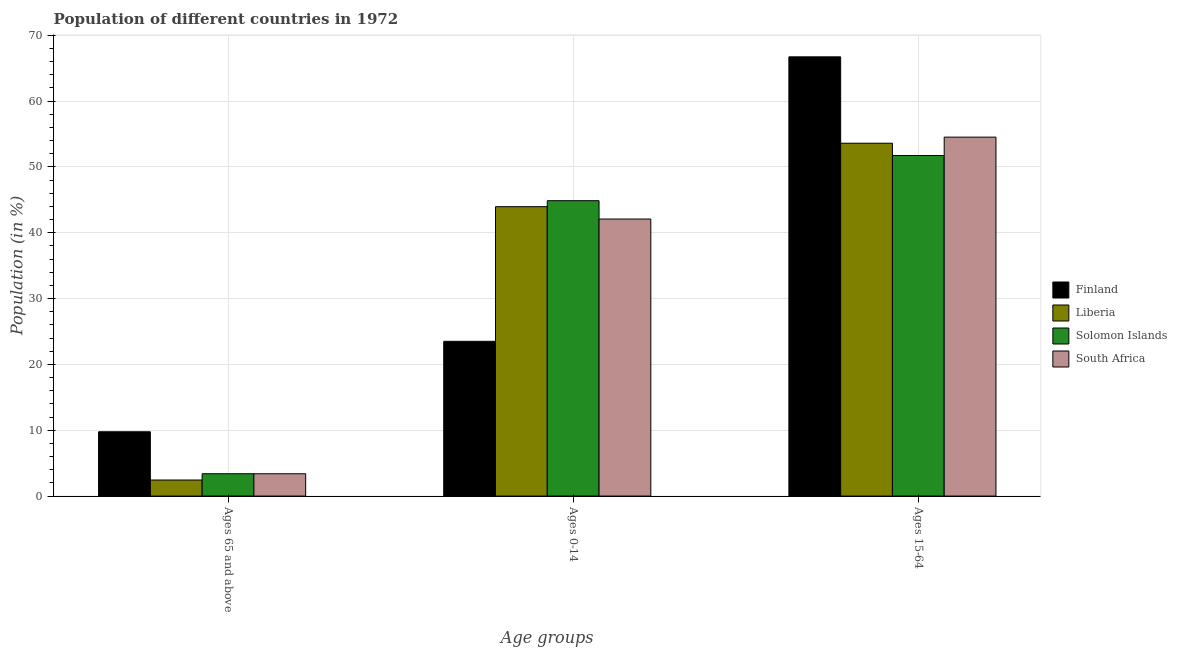How many different coloured bars are there?
Provide a short and direct response. 4. How many bars are there on the 2nd tick from the left?
Provide a succinct answer. 4. What is the label of the 3rd group of bars from the left?
Keep it short and to the point. Ages 15-64. What is the percentage of population within the age-group 15-64 in South Africa?
Your answer should be compact. 54.53. Across all countries, what is the maximum percentage of population within the age-group 0-14?
Give a very brief answer. 44.87. Across all countries, what is the minimum percentage of population within the age-group of 65 and above?
Offer a terse response. 2.44. In which country was the percentage of population within the age-group 15-64 minimum?
Provide a succinct answer. Solomon Islands. What is the total percentage of population within the age-group 15-64 in the graph?
Make the answer very short. 226.59. What is the difference between the percentage of population within the age-group 0-14 in Solomon Islands and that in Liberia?
Provide a succinct answer. 0.91. What is the difference between the percentage of population within the age-group of 65 and above in Liberia and the percentage of population within the age-group 0-14 in Solomon Islands?
Offer a terse response. -42.43. What is the average percentage of population within the age-group of 65 and above per country?
Ensure brevity in your answer.  4.75. What is the difference between the percentage of population within the age-group 15-64 and percentage of population within the age-group of 65 and above in South Africa?
Keep it short and to the point. 51.14. What is the ratio of the percentage of population within the age-group 0-14 in Solomon Islands to that in Liberia?
Keep it short and to the point. 1.02. Is the percentage of population within the age-group of 65 and above in Liberia less than that in Solomon Islands?
Ensure brevity in your answer.  Yes. What is the difference between the highest and the second highest percentage of population within the age-group of 65 and above?
Ensure brevity in your answer.  6.37. What is the difference between the highest and the lowest percentage of population within the age-group 0-14?
Provide a short and direct response. 21.36. What does the 3rd bar from the left in Ages 15-64 represents?
Keep it short and to the point. Solomon Islands. What does the 1st bar from the right in Ages 0-14 represents?
Offer a terse response. South Africa. Is it the case that in every country, the sum of the percentage of population within the age-group of 65 and above and percentage of population within the age-group 0-14 is greater than the percentage of population within the age-group 15-64?
Make the answer very short. No. How many bars are there?
Provide a succinct answer. 12. Are all the bars in the graph horizontal?
Keep it short and to the point. No. Does the graph contain any zero values?
Keep it short and to the point. No. Does the graph contain grids?
Your answer should be very brief. Yes. Where does the legend appear in the graph?
Give a very brief answer. Center right. What is the title of the graph?
Your response must be concise. Population of different countries in 1972. Does "Norway" appear as one of the legend labels in the graph?
Your response must be concise. No. What is the label or title of the X-axis?
Provide a short and direct response. Age groups. What is the label or title of the Y-axis?
Keep it short and to the point. Population (in %). What is the Population (in %) of Finland in Ages 65 and above?
Keep it short and to the point. 9.77. What is the Population (in %) in Liberia in Ages 65 and above?
Give a very brief answer. 2.44. What is the Population (in %) in Solomon Islands in Ages 65 and above?
Your answer should be very brief. 3.39. What is the Population (in %) in South Africa in Ages 65 and above?
Make the answer very short. 3.39. What is the Population (in %) of Finland in Ages 0-14?
Provide a succinct answer. 23.51. What is the Population (in %) in Liberia in Ages 0-14?
Provide a short and direct response. 43.96. What is the Population (in %) of Solomon Islands in Ages 0-14?
Keep it short and to the point. 44.87. What is the Population (in %) in South Africa in Ages 0-14?
Provide a succinct answer. 42.08. What is the Population (in %) of Finland in Ages 15-64?
Your answer should be very brief. 66.72. What is the Population (in %) of Liberia in Ages 15-64?
Your answer should be very brief. 53.6. What is the Population (in %) in Solomon Islands in Ages 15-64?
Give a very brief answer. 51.74. What is the Population (in %) of South Africa in Ages 15-64?
Offer a terse response. 54.53. Across all Age groups, what is the maximum Population (in %) of Finland?
Your response must be concise. 66.72. Across all Age groups, what is the maximum Population (in %) of Liberia?
Keep it short and to the point. 53.6. Across all Age groups, what is the maximum Population (in %) in Solomon Islands?
Give a very brief answer. 51.74. Across all Age groups, what is the maximum Population (in %) in South Africa?
Your answer should be compact. 54.53. Across all Age groups, what is the minimum Population (in %) in Finland?
Keep it short and to the point. 9.77. Across all Age groups, what is the minimum Population (in %) in Liberia?
Offer a terse response. 2.44. Across all Age groups, what is the minimum Population (in %) in Solomon Islands?
Provide a succinct answer. 3.39. Across all Age groups, what is the minimum Population (in %) in South Africa?
Offer a terse response. 3.39. What is the difference between the Population (in %) in Finland in Ages 65 and above and that in Ages 0-14?
Provide a succinct answer. -13.74. What is the difference between the Population (in %) in Liberia in Ages 65 and above and that in Ages 0-14?
Keep it short and to the point. -41.52. What is the difference between the Population (in %) of Solomon Islands in Ages 65 and above and that in Ages 0-14?
Your answer should be compact. -41.48. What is the difference between the Population (in %) of South Africa in Ages 65 and above and that in Ages 0-14?
Your answer should be very brief. -38.69. What is the difference between the Population (in %) in Finland in Ages 65 and above and that in Ages 15-64?
Offer a very short reply. -56.95. What is the difference between the Population (in %) of Liberia in Ages 65 and above and that in Ages 15-64?
Your answer should be compact. -51.16. What is the difference between the Population (in %) in Solomon Islands in Ages 65 and above and that in Ages 15-64?
Offer a very short reply. -48.34. What is the difference between the Population (in %) in South Africa in Ages 65 and above and that in Ages 15-64?
Offer a very short reply. -51.14. What is the difference between the Population (in %) in Finland in Ages 0-14 and that in Ages 15-64?
Provide a short and direct response. -43.22. What is the difference between the Population (in %) in Liberia in Ages 0-14 and that in Ages 15-64?
Your answer should be very brief. -9.64. What is the difference between the Population (in %) of Solomon Islands in Ages 0-14 and that in Ages 15-64?
Provide a succinct answer. -6.87. What is the difference between the Population (in %) in South Africa in Ages 0-14 and that in Ages 15-64?
Provide a short and direct response. -12.44. What is the difference between the Population (in %) of Finland in Ages 65 and above and the Population (in %) of Liberia in Ages 0-14?
Give a very brief answer. -34.19. What is the difference between the Population (in %) in Finland in Ages 65 and above and the Population (in %) in Solomon Islands in Ages 0-14?
Offer a terse response. -35.1. What is the difference between the Population (in %) of Finland in Ages 65 and above and the Population (in %) of South Africa in Ages 0-14?
Offer a very short reply. -32.32. What is the difference between the Population (in %) of Liberia in Ages 65 and above and the Population (in %) of Solomon Islands in Ages 0-14?
Give a very brief answer. -42.43. What is the difference between the Population (in %) of Liberia in Ages 65 and above and the Population (in %) of South Africa in Ages 0-14?
Make the answer very short. -39.65. What is the difference between the Population (in %) of Solomon Islands in Ages 65 and above and the Population (in %) of South Africa in Ages 0-14?
Provide a succinct answer. -38.69. What is the difference between the Population (in %) in Finland in Ages 65 and above and the Population (in %) in Liberia in Ages 15-64?
Keep it short and to the point. -43.83. What is the difference between the Population (in %) of Finland in Ages 65 and above and the Population (in %) of Solomon Islands in Ages 15-64?
Provide a short and direct response. -41.97. What is the difference between the Population (in %) of Finland in Ages 65 and above and the Population (in %) of South Africa in Ages 15-64?
Ensure brevity in your answer.  -44.76. What is the difference between the Population (in %) of Liberia in Ages 65 and above and the Population (in %) of Solomon Islands in Ages 15-64?
Keep it short and to the point. -49.3. What is the difference between the Population (in %) of Liberia in Ages 65 and above and the Population (in %) of South Africa in Ages 15-64?
Your answer should be compact. -52.09. What is the difference between the Population (in %) of Solomon Islands in Ages 65 and above and the Population (in %) of South Africa in Ages 15-64?
Your answer should be compact. -51.13. What is the difference between the Population (in %) of Finland in Ages 0-14 and the Population (in %) of Liberia in Ages 15-64?
Ensure brevity in your answer.  -30.09. What is the difference between the Population (in %) of Finland in Ages 0-14 and the Population (in %) of Solomon Islands in Ages 15-64?
Offer a very short reply. -28.23. What is the difference between the Population (in %) in Finland in Ages 0-14 and the Population (in %) in South Africa in Ages 15-64?
Offer a terse response. -31.02. What is the difference between the Population (in %) of Liberia in Ages 0-14 and the Population (in %) of Solomon Islands in Ages 15-64?
Your answer should be very brief. -7.77. What is the difference between the Population (in %) of Liberia in Ages 0-14 and the Population (in %) of South Africa in Ages 15-64?
Make the answer very short. -10.56. What is the difference between the Population (in %) in Solomon Islands in Ages 0-14 and the Population (in %) in South Africa in Ages 15-64?
Keep it short and to the point. -9.66. What is the average Population (in %) of Finland per Age groups?
Your answer should be very brief. 33.33. What is the average Population (in %) in Liberia per Age groups?
Your answer should be compact. 33.33. What is the average Population (in %) in Solomon Islands per Age groups?
Provide a short and direct response. 33.33. What is the average Population (in %) in South Africa per Age groups?
Offer a very short reply. 33.33. What is the difference between the Population (in %) of Finland and Population (in %) of Liberia in Ages 65 and above?
Provide a succinct answer. 7.33. What is the difference between the Population (in %) of Finland and Population (in %) of Solomon Islands in Ages 65 and above?
Your answer should be compact. 6.37. What is the difference between the Population (in %) of Finland and Population (in %) of South Africa in Ages 65 and above?
Your answer should be compact. 6.38. What is the difference between the Population (in %) of Liberia and Population (in %) of Solomon Islands in Ages 65 and above?
Your answer should be compact. -0.96. What is the difference between the Population (in %) of Liberia and Population (in %) of South Africa in Ages 65 and above?
Your answer should be compact. -0.95. What is the difference between the Population (in %) of Solomon Islands and Population (in %) of South Africa in Ages 65 and above?
Ensure brevity in your answer.  0. What is the difference between the Population (in %) of Finland and Population (in %) of Liberia in Ages 0-14?
Your answer should be very brief. -20.45. What is the difference between the Population (in %) of Finland and Population (in %) of Solomon Islands in Ages 0-14?
Provide a succinct answer. -21.36. What is the difference between the Population (in %) of Finland and Population (in %) of South Africa in Ages 0-14?
Make the answer very short. -18.58. What is the difference between the Population (in %) of Liberia and Population (in %) of Solomon Islands in Ages 0-14?
Provide a succinct answer. -0.91. What is the difference between the Population (in %) in Liberia and Population (in %) in South Africa in Ages 0-14?
Ensure brevity in your answer.  1.88. What is the difference between the Population (in %) of Solomon Islands and Population (in %) of South Africa in Ages 0-14?
Provide a succinct answer. 2.79. What is the difference between the Population (in %) of Finland and Population (in %) of Liberia in Ages 15-64?
Make the answer very short. 13.12. What is the difference between the Population (in %) of Finland and Population (in %) of Solomon Islands in Ages 15-64?
Your response must be concise. 14.99. What is the difference between the Population (in %) in Finland and Population (in %) in South Africa in Ages 15-64?
Provide a short and direct response. 12.2. What is the difference between the Population (in %) in Liberia and Population (in %) in Solomon Islands in Ages 15-64?
Offer a very short reply. 1.87. What is the difference between the Population (in %) in Liberia and Population (in %) in South Africa in Ages 15-64?
Make the answer very short. -0.93. What is the difference between the Population (in %) in Solomon Islands and Population (in %) in South Africa in Ages 15-64?
Give a very brief answer. -2.79. What is the ratio of the Population (in %) in Finland in Ages 65 and above to that in Ages 0-14?
Keep it short and to the point. 0.42. What is the ratio of the Population (in %) of Liberia in Ages 65 and above to that in Ages 0-14?
Make the answer very short. 0.06. What is the ratio of the Population (in %) of Solomon Islands in Ages 65 and above to that in Ages 0-14?
Offer a very short reply. 0.08. What is the ratio of the Population (in %) in South Africa in Ages 65 and above to that in Ages 0-14?
Provide a short and direct response. 0.08. What is the ratio of the Population (in %) of Finland in Ages 65 and above to that in Ages 15-64?
Your answer should be very brief. 0.15. What is the ratio of the Population (in %) in Liberia in Ages 65 and above to that in Ages 15-64?
Ensure brevity in your answer.  0.05. What is the ratio of the Population (in %) of Solomon Islands in Ages 65 and above to that in Ages 15-64?
Provide a succinct answer. 0.07. What is the ratio of the Population (in %) of South Africa in Ages 65 and above to that in Ages 15-64?
Your answer should be compact. 0.06. What is the ratio of the Population (in %) in Finland in Ages 0-14 to that in Ages 15-64?
Give a very brief answer. 0.35. What is the ratio of the Population (in %) of Liberia in Ages 0-14 to that in Ages 15-64?
Provide a short and direct response. 0.82. What is the ratio of the Population (in %) in Solomon Islands in Ages 0-14 to that in Ages 15-64?
Keep it short and to the point. 0.87. What is the ratio of the Population (in %) in South Africa in Ages 0-14 to that in Ages 15-64?
Ensure brevity in your answer.  0.77. What is the difference between the highest and the second highest Population (in %) of Finland?
Offer a terse response. 43.22. What is the difference between the highest and the second highest Population (in %) in Liberia?
Offer a very short reply. 9.64. What is the difference between the highest and the second highest Population (in %) of Solomon Islands?
Your answer should be compact. 6.87. What is the difference between the highest and the second highest Population (in %) in South Africa?
Offer a terse response. 12.44. What is the difference between the highest and the lowest Population (in %) in Finland?
Keep it short and to the point. 56.95. What is the difference between the highest and the lowest Population (in %) in Liberia?
Keep it short and to the point. 51.16. What is the difference between the highest and the lowest Population (in %) in Solomon Islands?
Your answer should be very brief. 48.34. What is the difference between the highest and the lowest Population (in %) of South Africa?
Provide a succinct answer. 51.14. 